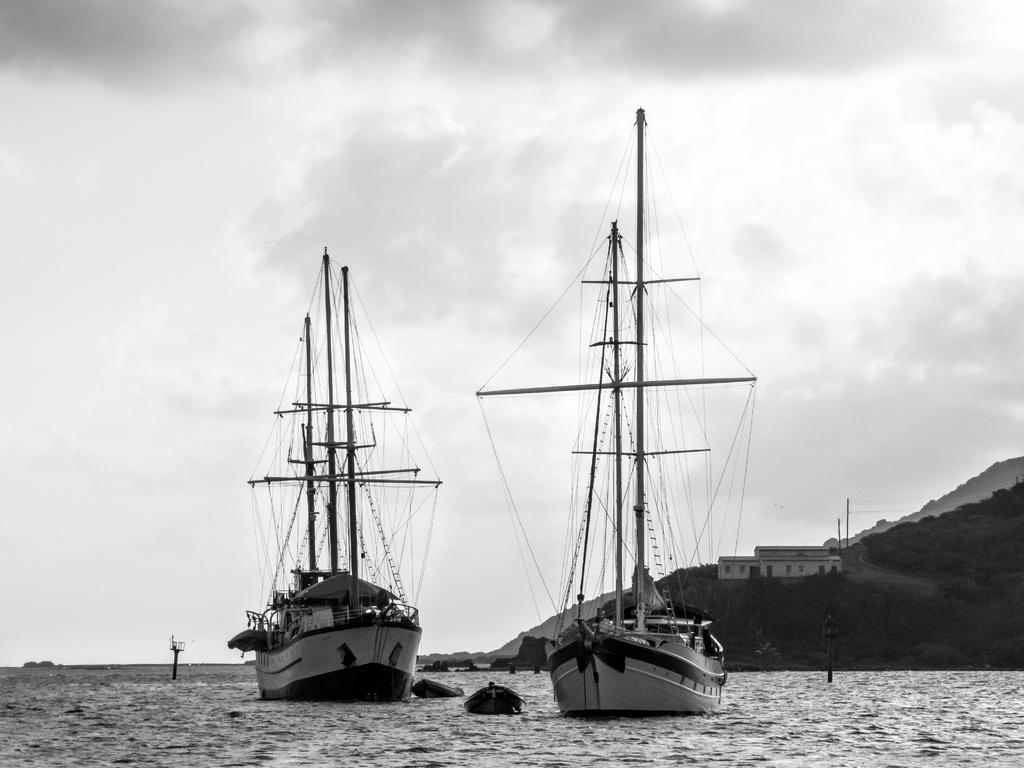In one or two sentences, can you explain what this image depicts? In this picture we can see a few boats in the water. There are some objects in the water. We can see a house and poles in the background. Sky is cloudy. 